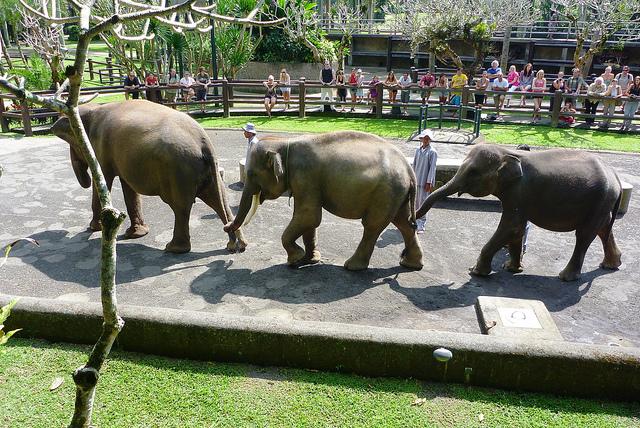Which animal has the longest horns?
Concise answer only. Middle. Are the elephant trainers wearing hats?
Write a very short answer. Yes. What body part are the animals holding?
Keep it brief. Tail. Is this photo taken at night?
Write a very short answer. No. 